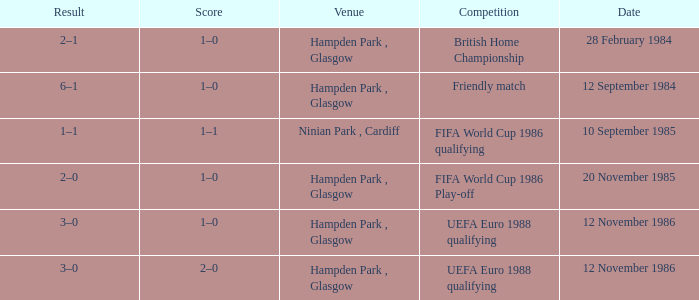Can you parse all the data within this table? {'header': ['Result', 'Score', 'Venue', 'Competition', 'Date'], 'rows': [['2–1', '1–0', 'Hampden Park , Glasgow', 'British Home Championship', '28 February 1984'], ['6–1', '1–0', 'Hampden Park , Glasgow', 'Friendly match', '12 September 1984'], ['1–1', '1–1', 'Ninian Park , Cardiff', 'FIFA World Cup 1986 qualifying', '10 September 1985'], ['2–0', '1–0', 'Hampden Park , Glasgow', 'FIFA World Cup 1986 Play-off', '20 November 1985'], ['3–0', '1–0', 'Hampden Park , Glasgow', 'UEFA Euro 1988 qualifying', '12 November 1986'], ['3–0', '2–0', 'Hampden Park , Glasgow', 'UEFA Euro 1988 qualifying', '12 November 1986']]} What is the Date of the Competition with a Result of 3–0? 12 November 1986, 12 November 1986. 